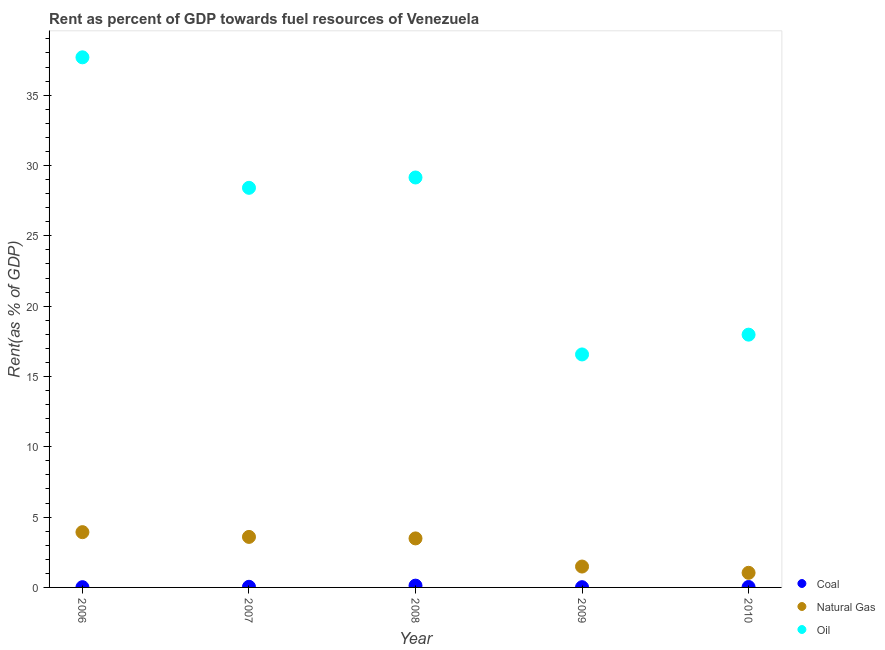Is the number of dotlines equal to the number of legend labels?
Offer a terse response. Yes. What is the rent towards coal in 2009?
Ensure brevity in your answer.  0.02. Across all years, what is the maximum rent towards coal?
Offer a very short reply. 0.13. Across all years, what is the minimum rent towards oil?
Ensure brevity in your answer.  16.57. In which year was the rent towards natural gas maximum?
Ensure brevity in your answer.  2006. In which year was the rent towards coal minimum?
Your answer should be compact. 2006. What is the total rent towards natural gas in the graph?
Make the answer very short. 13.53. What is the difference between the rent towards oil in 2007 and that in 2010?
Offer a very short reply. 10.44. What is the difference between the rent towards natural gas in 2007 and the rent towards coal in 2006?
Ensure brevity in your answer.  3.57. What is the average rent towards oil per year?
Your response must be concise. 25.96. In the year 2010, what is the difference between the rent towards oil and rent towards natural gas?
Provide a short and direct response. 16.93. In how many years, is the rent towards natural gas greater than 24 %?
Offer a terse response. 0. What is the ratio of the rent towards coal in 2007 to that in 2010?
Provide a succinct answer. 1.46. Is the rent towards natural gas in 2006 less than that in 2010?
Offer a very short reply. No. Is the difference between the rent towards oil in 2006 and 2009 greater than the difference between the rent towards coal in 2006 and 2009?
Offer a terse response. Yes. What is the difference between the highest and the second highest rent towards coal?
Offer a terse response. 0.08. What is the difference between the highest and the lowest rent towards natural gas?
Offer a very short reply. 2.89. Is it the case that in every year, the sum of the rent towards coal and rent towards natural gas is greater than the rent towards oil?
Offer a very short reply. No. How many dotlines are there?
Give a very brief answer. 3. How many years are there in the graph?
Give a very brief answer. 5. What is the title of the graph?
Offer a terse response. Rent as percent of GDP towards fuel resources of Venezuela. Does "Spain" appear as one of the legend labels in the graph?
Provide a short and direct response. No. What is the label or title of the Y-axis?
Offer a terse response. Rent(as % of GDP). What is the Rent(as % of GDP) in Coal in 2006?
Offer a terse response. 0.02. What is the Rent(as % of GDP) in Natural Gas in 2006?
Provide a short and direct response. 3.93. What is the Rent(as % of GDP) in Oil in 2006?
Ensure brevity in your answer.  37.69. What is the Rent(as % of GDP) in Coal in 2007?
Your response must be concise. 0.04. What is the Rent(as % of GDP) of Natural Gas in 2007?
Your response must be concise. 3.59. What is the Rent(as % of GDP) of Oil in 2007?
Give a very brief answer. 28.41. What is the Rent(as % of GDP) of Coal in 2008?
Keep it short and to the point. 0.13. What is the Rent(as % of GDP) in Natural Gas in 2008?
Offer a terse response. 3.49. What is the Rent(as % of GDP) in Oil in 2008?
Keep it short and to the point. 29.15. What is the Rent(as % of GDP) in Coal in 2009?
Offer a very short reply. 0.02. What is the Rent(as % of GDP) in Natural Gas in 2009?
Ensure brevity in your answer.  1.48. What is the Rent(as % of GDP) of Oil in 2009?
Keep it short and to the point. 16.57. What is the Rent(as % of GDP) of Coal in 2010?
Your response must be concise. 0.03. What is the Rent(as % of GDP) of Natural Gas in 2010?
Provide a short and direct response. 1.04. What is the Rent(as % of GDP) in Oil in 2010?
Offer a very short reply. 17.97. Across all years, what is the maximum Rent(as % of GDP) of Coal?
Offer a terse response. 0.13. Across all years, what is the maximum Rent(as % of GDP) of Natural Gas?
Provide a succinct answer. 3.93. Across all years, what is the maximum Rent(as % of GDP) of Oil?
Make the answer very short. 37.69. Across all years, what is the minimum Rent(as % of GDP) of Coal?
Ensure brevity in your answer.  0.02. Across all years, what is the minimum Rent(as % of GDP) in Natural Gas?
Provide a succinct answer. 1.04. Across all years, what is the minimum Rent(as % of GDP) in Oil?
Make the answer very short. 16.57. What is the total Rent(as % of GDP) in Coal in the graph?
Offer a very short reply. 0.24. What is the total Rent(as % of GDP) of Natural Gas in the graph?
Give a very brief answer. 13.53. What is the total Rent(as % of GDP) in Oil in the graph?
Give a very brief answer. 129.79. What is the difference between the Rent(as % of GDP) of Coal in 2006 and that in 2007?
Keep it short and to the point. -0.03. What is the difference between the Rent(as % of GDP) of Natural Gas in 2006 and that in 2007?
Ensure brevity in your answer.  0.34. What is the difference between the Rent(as % of GDP) in Oil in 2006 and that in 2007?
Ensure brevity in your answer.  9.28. What is the difference between the Rent(as % of GDP) in Coal in 2006 and that in 2008?
Your answer should be very brief. -0.11. What is the difference between the Rent(as % of GDP) in Natural Gas in 2006 and that in 2008?
Your answer should be compact. 0.44. What is the difference between the Rent(as % of GDP) of Oil in 2006 and that in 2008?
Your answer should be very brief. 8.54. What is the difference between the Rent(as % of GDP) in Coal in 2006 and that in 2009?
Provide a succinct answer. -0. What is the difference between the Rent(as % of GDP) in Natural Gas in 2006 and that in 2009?
Your answer should be compact. 2.45. What is the difference between the Rent(as % of GDP) in Oil in 2006 and that in 2009?
Ensure brevity in your answer.  21.13. What is the difference between the Rent(as % of GDP) of Coal in 2006 and that in 2010?
Provide a short and direct response. -0.01. What is the difference between the Rent(as % of GDP) of Natural Gas in 2006 and that in 2010?
Make the answer very short. 2.89. What is the difference between the Rent(as % of GDP) of Oil in 2006 and that in 2010?
Ensure brevity in your answer.  19.72. What is the difference between the Rent(as % of GDP) in Coal in 2007 and that in 2008?
Provide a succinct answer. -0.08. What is the difference between the Rent(as % of GDP) in Natural Gas in 2007 and that in 2008?
Offer a terse response. 0.11. What is the difference between the Rent(as % of GDP) in Oil in 2007 and that in 2008?
Ensure brevity in your answer.  -0.74. What is the difference between the Rent(as % of GDP) of Coal in 2007 and that in 2009?
Provide a short and direct response. 0.03. What is the difference between the Rent(as % of GDP) in Natural Gas in 2007 and that in 2009?
Your answer should be compact. 2.11. What is the difference between the Rent(as % of GDP) in Oil in 2007 and that in 2009?
Give a very brief answer. 11.85. What is the difference between the Rent(as % of GDP) in Coal in 2007 and that in 2010?
Give a very brief answer. 0.01. What is the difference between the Rent(as % of GDP) in Natural Gas in 2007 and that in 2010?
Provide a succinct answer. 2.55. What is the difference between the Rent(as % of GDP) in Oil in 2007 and that in 2010?
Keep it short and to the point. 10.44. What is the difference between the Rent(as % of GDP) of Coal in 2008 and that in 2009?
Offer a terse response. 0.11. What is the difference between the Rent(as % of GDP) of Natural Gas in 2008 and that in 2009?
Your response must be concise. 2. What is the difference between the Rent(as % of GDP) of Oil in 2008 and that in 2009?
Make the answer very short. 12.58. What is the difference between the Rent(as % of GDP) in Coal in 2008 and that in 2010?
Make the answer very short. 0.1. What is the difference between the Rent(as % of GDP) of Natural Gas in 2008 and that in 2010?
Ensure brevity in your answer.  2.45. What is the difference between the Rent(as % of GDP) in Oil in 2008 and that in 2010?
Provide a short and direct response. 11.17. What is the difference between the Rent(as % of GDP) in Coal in 2009 and that in 2010?
Your answer should be compact. -0.01. What is the difference between the Rent(as % of GDP) in Natural Gas in 2009 and that in 2010?
Your answer should be compact. 0.45. What is the difference between the Rent(as % of GDP) of Oil in 2009 and that in 2010?
Ensure brevity in your answer.  -1.41. What is the difference between the Rent(as % of GDP) of Coal in 2006 and the Rent(as % of GDP) of Natural Gas in 2007?
Keep it short and to the point. -3.58. What is the difference between the Rent(as % of GDP) in Coal in 2006 and the Rent(as % of GDP) in Oil in 2007?
Give a very brief answer. -28.39. What is the difference between the Rent(as % of GDP) in Natural Gas in 2006 and the Rent(as % of GDP) in Oil in 2007?
Provide a succinct answer. -24.48. What is the difference between the Rent(as % of GDP) in Coal in 2006 and the Rent(as % of GDP) in Natural Gas in 2008?
Your answer should be very brief. -3.47. What is the difference between the Rent(as % of GDP) in Coal in 2006 and the Rent(as % of GDP) in Oil in 2008?
Offer a terse response. -29.13. What is the difference between the Rent(as % of GDP) in Natural Gas in 2006 and the Rent(as % of GDP) in Oil in 2008?
Ensure brevity in your answer.  -25.22. What is the difference between the Rent(as % of GDP) in Coal in 2006 and the Rent(as % of GDP) in Natural Gas in 2009?
Your response must be concise. -1.47. What is the difference between the Rent(as % of GDP) in Coal in 2006 and the Rent(as % of GDP) in Oil in 2009?
Keep it short and to the point. -16.55. What is the difference between the Rent(as % of GDP) of Natural Gas in 2006 and the Rent(as % of GDP) of Oil in 2009?
Provide a succinct answer. -12.64. What is the difference between the Rent(as % of GDP) in Coal in 2006 and the Rent(as % of GDP) in Natural Gas in 2010?
Your response must be concise. -1.02. What is the difference between the Rent(as % of GDP) of Coal in 2006 and the Rent(as % of GDP) of Oil in 2010?
Ensure brevity in your answer.  -17.96. What is the difference between the Rent(as % of GDP) of Natural Gas in 2006 and the Rent(as % of GDP) of Oil in 2010?
Offer a terse response. -14.04. What is the difference between the Rent(as % of GDP) in Coal in 2007 and the Rent(as % of GDP) in Natural Gas in 2008?
Offer a very short reply. -3.44. What is the difference between the Rent(as % of GDP) of Coal in 2007 and the Rent(as % of GDP) of Oil in 2008?
Make the answer very short. -29.1. What is the difference between the Rent(as % of GDP) in Natural Gas in 2007 and the Rent(as % of GDP) in Oil in 2008?
Your response must be concise. -25.55. What is the difference between the Rent(as % of GDP) in Coal in 2007 and the Rent(as % of GDP) in Natural Gas in 2009?
Offer a terse response. -1.44. What is the difference between the Rent(as % of GDP) in Coal in 2007 and the Rent(as % of GDP) in Oil in 2009?
Your response must be concise. -16.52. What is the difference between the Rent(as % of GDP) in Natural Gas in 2007 and the Rent(as % of GDP) in Oil in 2009?
Offer a terse response. -12.97. What is the difference between the Rent(as % of GDP) of Coal in 2007 and the Rent(as % of GDP) of Natural Gas in 2010?
Offer a very short reply. -0.99. What is the difference between the Rent(as % of GDP) in Coal in 2007 and the Rent(as % of GDP) in Oil in 2010?
Your answer should be compact. -17.93. What is the difference between the Rent(as % of GDP) of Natural Gas in 2007 and the Rent(as % of GDP) of Oil in 2010?
Ensure brevity in your answer.  -14.38. What is the difference between the Rent(as % of GDP) of Coal in 2008 and the Rent(as % of GDP) of Natural Gas in 2009?
Give a very brief answer. -1.36. What is the difference between the Rent(as % of GDP) of Coal in 2008 and the Rent(as % of GDP) of Oil in 2009?
Your answer should be very brief. -16.44. What is the difference between the Rent(as % of GDP) in Natural Gas in 2008 and the Rent(as % of GDP) in Oil in 2009?
Provide a succinct answer. -13.08. What is the difference between the Rent(as % of GDP) in Coal in 2008 and the Rent(as % of GDP) in Natural Gas in 2010?
Offer a terse response. -0.91. What is the difference between the Rent(as % of GDP) of Coal in 2008 and the Rent(as % of GDP) of Oil in 2010?
Ensure brevity in your answer.  -17.85. What is the difference between the Rent(as % of GDP) of Natural Gas in 2008 and the Rent(as % of GDP) of Oil in 2010?
Make the answer very short. -14.49. What is the difference between the Rent(as % of GDP) of Coal in 2009 and the Rent(as % of GDP) of Natural Gas in 2010?
Keep it short and to the point. -1.02. What is the difference between the Rent(as % of GDP) in Coal in 2009 and the Rent(as % of GDP) in Oil in 2010?
Give a very brief answer. -17.95. What is the difference between the Rent(as % of GDP) of Natural Gas in 2009 and the Rent(as % of GDP) of Oil in 2010?
Your answer should be very brief. -16.49. What is the average Rent(as % of GDP) of Coal per year?
Make the answer very short. 0.05. What is the average Rent(as % of GDP) in Natural Gas per year?
Offer a very short reply. 2.71. What is the average Rent(as % of GDP) in Oil per year?
Offer a very short reply. 25.96. In the year 2006, what is the difference between the Rent(as % of GDP) of Coal and Rent(as % of GDP) of Natural Gas?
Your response must be concise. -3.91. In the year 2006, what is the difference between the Rent(as % of GDP) in Coal and Rent(as % of GDP) in Oil?
Keep it short and to the point. -37.67. In the year 2006, what is the difference between the Rent(as % of GDP) in Natural Gas and Rent(as % of GDP) in Oil?
Provide a succinct answer. -33.76. In the year 2007, what is the difference between the Rent(as % of GDP) of Coal and Rent(as % of GDP) of Natural Gas?
Ensure brevity in your answer.  -3.55. In the year 2007, what is the difference between the Rent(as % of GDP) of Coal and Rent(as % of GDP) of Oil?
Your answer should be very brief. -28.37. In the year 2007, what is the difference between the Rent(as % of GDP) of Natural Gas and Rent(as % of GDP) of Oil?
Your answer should be very brief. -24.82. In the year 2008, what is the difference between the Rent(as % of GDP) of Coal and Rent(as % of GDP) of Natural Gas?
Your answer should be very brief. -3.36. In the year 2008, what is the difference between the Rent(as % of GDP) of Coal and Rent(as % of GDP) of Oil?
Your response must be concise. -29.02. In the year 2008, what is the difference between the Rent(as % of GDP) in Natural Gas and Rent(as % of GDP) in Oil?
Make the answer very short. -25.66. In the year 2009, what is the difference between the Rent(as % of GDP) in Coal and Rent(as % of GDP) in Natural Gas?
Your answer should be very brief. -1.47. In the year 2009, what is the difference between the Rent(as % of GDP) in Coal and Rent(as % of GDP) in Oil?
Ensure brevity in your answer.  -16.55. In the year 2009, what is the difference between the Rent(as % of GDP) in Natural Gas and Rent(as % of GDP) in Oil?
Your answer should be compact. -15.08. In the year 2010, what is the difference between the Rent(as % of GDP) in Coal and Rent(as % of GDP) in Natural Gas?
Provide a succinct answer. -1.01. In the year 2010, what is the difference between the Rent(as % of GDP) in Coal and Rent(as % of GDP) in Oil?
Ensure brevity in your answer.  -17.94. In the year 2010, what is the difference between the Rent(as % of GDP) of Natural Gas and Rent(as % of GDP) of Oil?
Keep it short and to the point. -16.93. What is the ratio of the Rent(as % of GDP) in Coal in 2006 to that in 2007?
Keep it short and to the point. 0.38. What is the ratio of the Rent(as % of GDP) in Natural Gas in 2006 to that in 2007?
Make the answer very short. 1.09. What is the ratio of the Rent(as % of GDP) in Oil in 2006 to that in 2007?
Make the answer very short. 1.33. What is the ratio of the Rent(as % of GDP) in Coal in 2006 to that in 2008?
Give a very brief answer. 0.13. What is the ratio of the Rent(as % of GDP) of Natural Gas in 2006 to that in 2008?
Provide a succinct answer. 1.13. What is the ratio of the Rent(as % of GDP) of Oil in 2006 to that in 2008?
Keep it short and to the point. 1.29. What is the ratio of the Rent(as % of GDP) of Coal in 2006 to that in 2009?
Provide a succinct answer. 0.97. What is the ratio of the Rent(as % of GDP) in Natural Gas in 2006 to that in 2009?
Your answer should be compact. 2.65. What is the ratio of the Rent(as % of GDP) of Oil in 2006 to that in 2009?
Your answer should be very brief. 2.28. What is the ratio of the Rent(as % of GDP) of Coal in 2006 to that in 2010?
Keep it short and to the point. 0.56. What is the ratio of the Rent(as % of GDP) of Natural Gas in 2006 to that in 2010?
Provide a short and direct response. 3.78. What is the ratio of the Rent(as % of GDP) in Oil in 2006 to that in 2010?
Your response must be concise. 2.1. What is the ratio of the Rent(as % of GDP) of Coal in 2007 to that in 2008?
Ensure brevity in your answer.  0.35. What is the ratio of the Rent(as % of GDP) in Natural Gas in 2007 to that in 2008?
Provide a short and direct response. 1.03. What is the ratio of the Rent(as % of GDP) of Oil in 2007 to that in 2008?
Your answer should be very brief. 0.97. What is the ratio of the Rent(as % of GDP) of Coal in 2007 to that in 2009?
Offer a terse response. 2.52. What is the ratio of the Rent(as % of GDP) in Natural Gas in 2007 to that in 2009?
Provide a succinct answer. 2.42. What is the ratio of the Rent(as % of GDP) in Oil in 2007 to that in 2009?
Keep it short and to the point. 1.72. What is the ratio of the Rent(as % of GDP) of Coal in 2007 to that in 2010?
Provide a succinct answer. 1.46. What is the ratio of the Rent(as % of GDP) of Natural Gas in 2007 to that in 2010?
Ensure brevity in your answer.  3.46. What is the ratio of the Rent(as % of GDP) of Oil in 2007 to that in 2010?
Give a very brief answer. 1.58. What is the ratio of the Rent(as % of GDP) in Coal in 2008 to that in 2009?
Make the answer very short. 7.22. What is the ratio of the Rent(as % of GDP) of Natural Gas in 2008 to that in 2009?
Keep it short and to the point. 2.35. What is the ratio of the Rent(as % of GDP) in Oil in 2008 to that in 2009?
Your response must be concise. 1.76. What is the ratio of the Rent(as % of GDP) of Coal in 2008 to that in 2010?
Your answer should be compact. 4.18. What is the ratio of the Rent(as % of GDP) in Natural Gas in 2008 to that in 2010?
Give a very brief answer. 3.35. What is the ratio of the Rent(as % of GDP) of Oil in 2008 to that in 2010?
Provide a succinct answer. 1.62. What is the ratio of the Rent(as % of GDP) in Coal in 2009 to that in 2010?
Your answer should be compact. 0.58. What is the ratio of the Rent(as % of GDP) of Natural Gas in 2009 to that in 2010?
Your answer should be very brief. 1.43. What is the ratio of the Rent(as % of GDP) of Oil in 2009 to that in 2010?
Ensure brevity in your answer.  0.92. What is the difference between the highest and the second highest Rent(as % of GDP) of Coal?
Give a very brief answer. 0.08. What is the difference between the highest and the second highest Rent(as % of GDP) in Natural Gas?
Your answer should be compact. 0.34. What is the difference between the highest and the second highest Rent(as % of GDP) of Oil?
Offer a very short reply. 8.54. What is the difference between the highest and the lowest Rent(as % of GDP) in Coal?
Your response must be concise. 0.11. What is the difference between the highest and the lowest Rent(as % of GDP) of Natural Gas?
Give a very brief answer. 2.89. What is the difference between the highest and the lowest Rent(as % of GDP) of Oil?
Give a very brief answer. 21.13. 